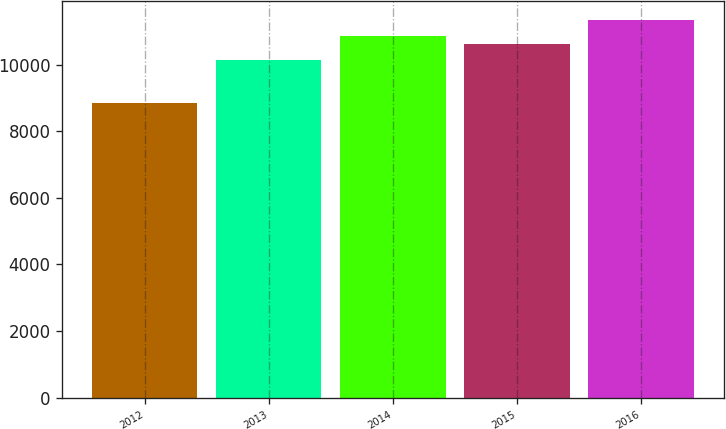Convert chart. <chart><loc_0><loc_0><loc_500><loc_500><bar_chart><fcel>2012<fcel>2013<fcel>2014<fcel>2015<fcel>2016<nl><fcel>8863<fcel>10134<fcel>10867.8<fcel>10620<fcel>11341<nl></chart> 